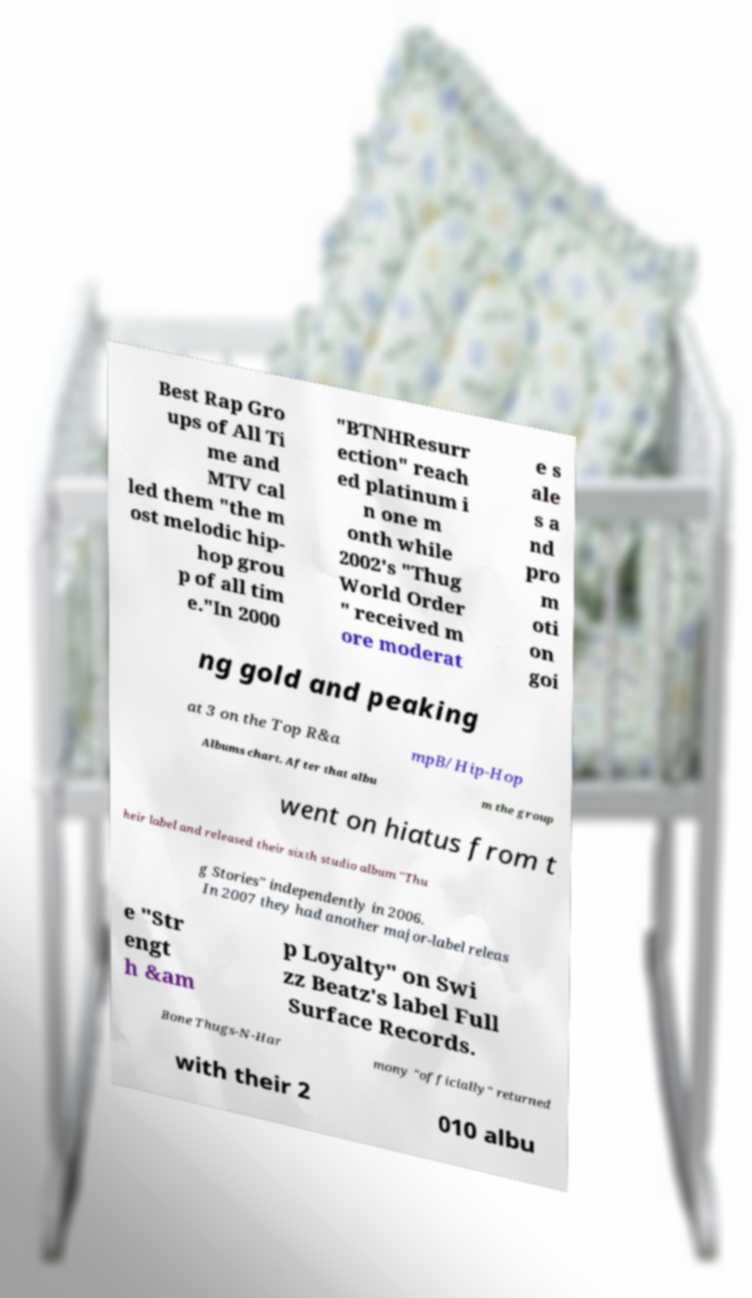What messages or text are displayed in this image? I need them in a readable, typed format. Best Rap Gro ups of All Ti me and MTV cal led them "the m ost melodic hip- hop grou p of all tim e."In 2000 "BTNHResurr ection" reach ed platinum i n one m onth while 2002's "Thug World Order " received m ore moderat e s ale s a nd pro m oti on goi ng gold and peaking at 3 on the Top R&a mpB/Hip-Hop Albums chart. After that albu m the group went on hiatus from t heir label and released their sixth studio album "Thu g Stories" independently in 2006. In 2007 they had another major-label releas e "Str engt h &am p Loyalty" on Swi zz Beatz's label Full Surface Records. Bone Thugs-N-Har mony "officially" returned with their 2 010 albu 